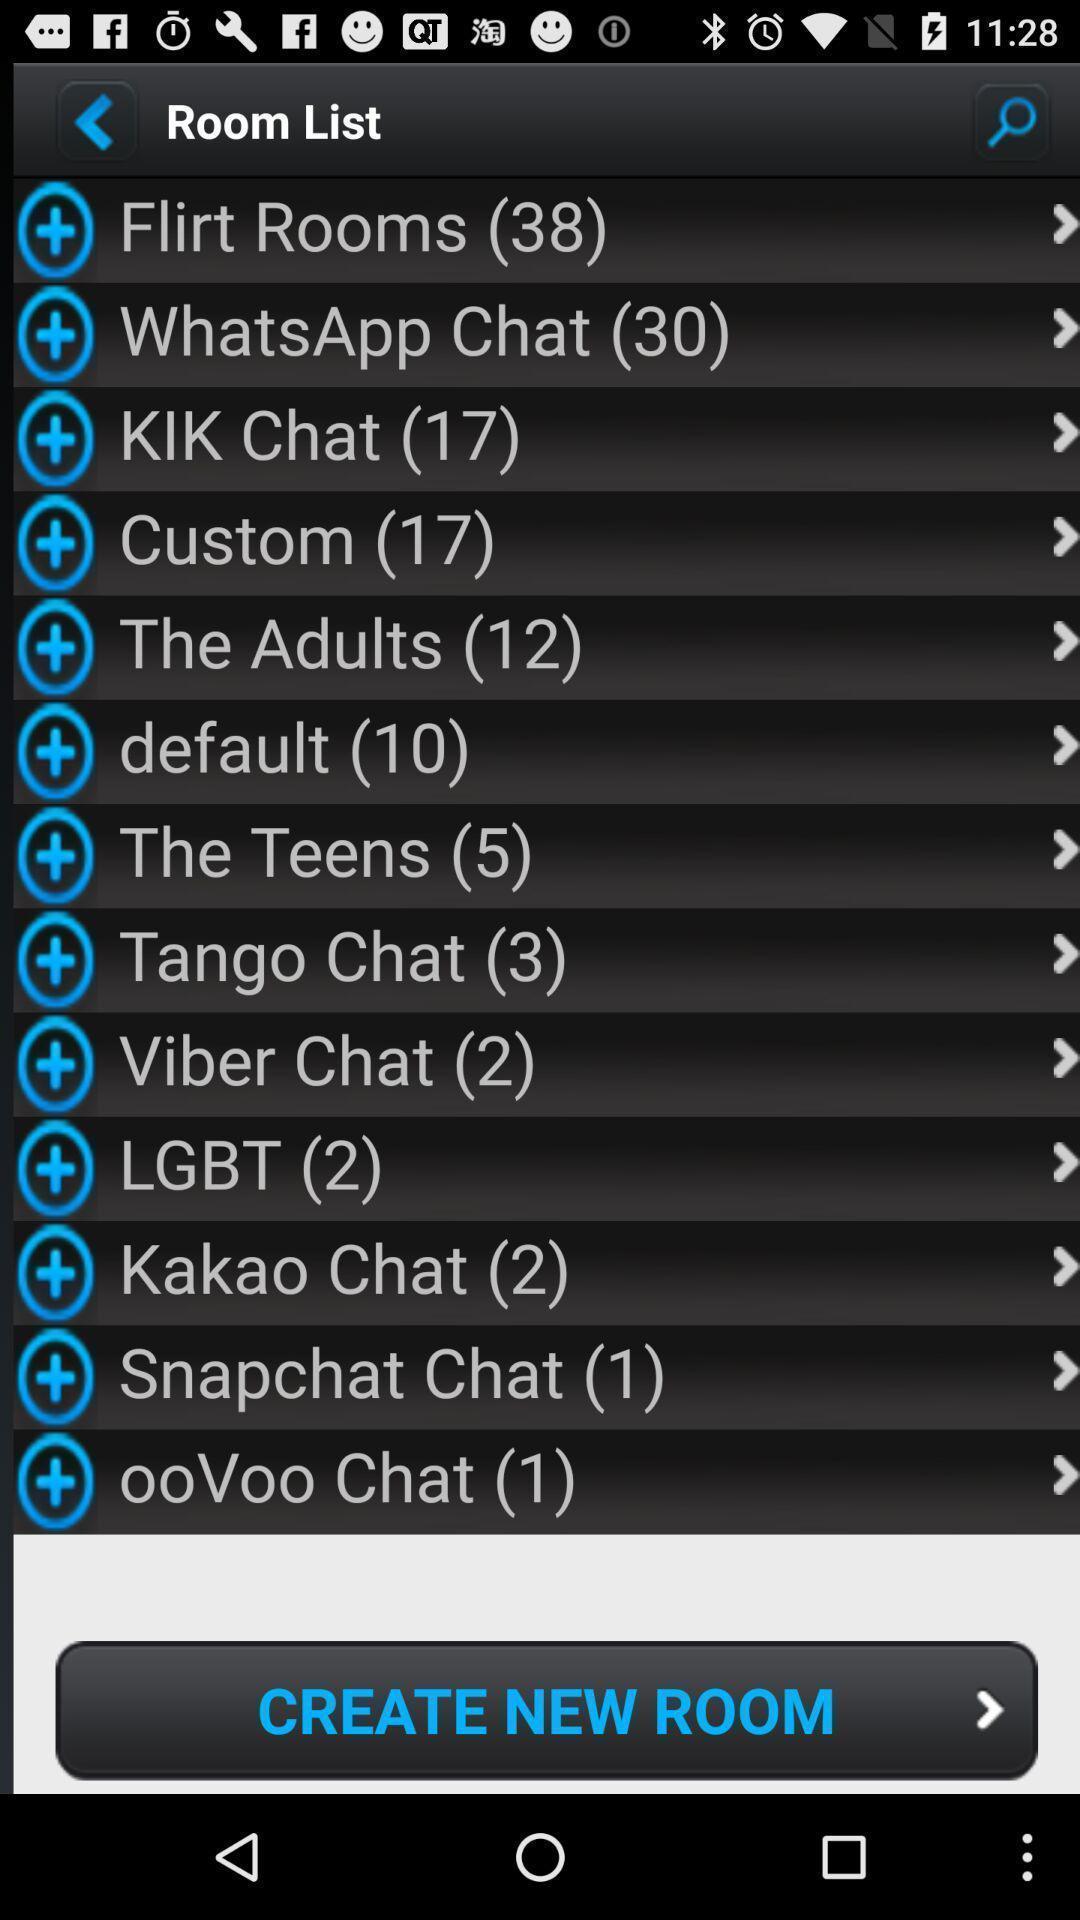Describe the key features of this screenshot. Screen shows list of options. 